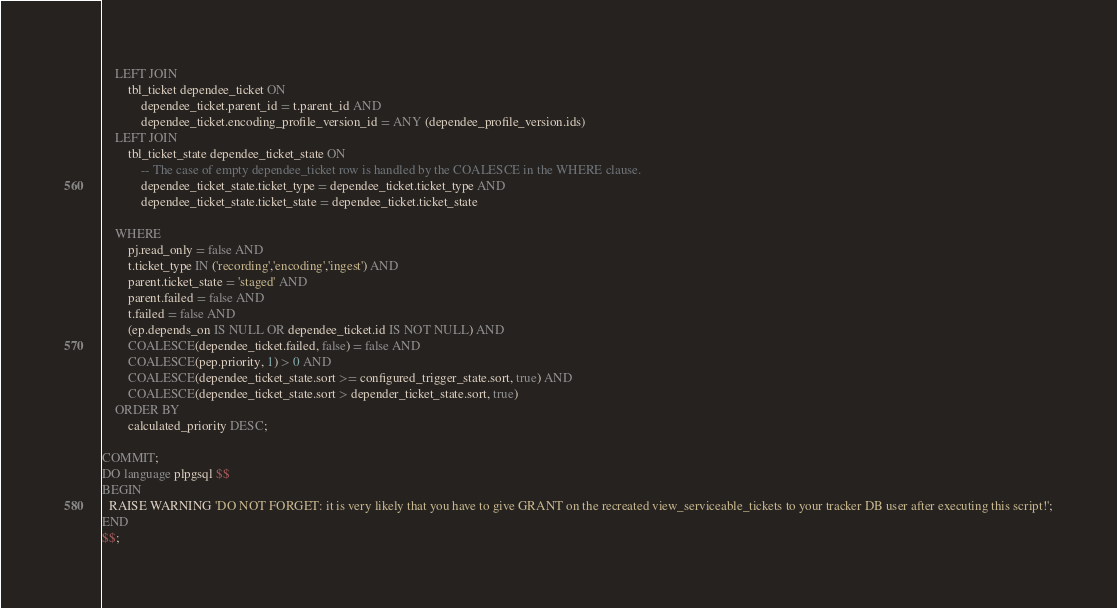<code> <loc_0><loc_0><loc_500><loc_500><_SQL_>	LEFT JOIN
		tbl_ticket dependee_ticket ON
			dependee_ticket.parent_id = t.parent_id AND
			dependee_ticket.encoding_profile_version_id = ANY (dependee_profile_version.ids)
	LEFT JOIN
		tbl_ticket_state dependee_ticket_state ON
			-- The case of empty dependee_ticket row is handled by the COALESCE in the WHERE clause.
			dependee_ticket_state.ticket_type = dependee_ticket.ticket_type AND
			dependee_ticket_state.ticket_state = dependee_ticket.ticket_state

	WHERE
		pj.read_only = false AND
		t.ticket_type IN ('recording','encoding','ingest') AND
		parent.ticket_state = 'staged' AND
		parent.failed = false AND
		t.failed = false AND
		(ep.depends_on IS NULL OR dependee_ticket.id IS NOT NULL) AND
		COALESCE(dependee_ticket.failed, false) = false AND
		COALESCE(pep.priority, 1) > 0 AND
		COALESCE(dependee_ticket_state.sort >= configured_trigger_state.sort, true) AND
		COALESCE(dependee_ticket_state.sort > depender_ticket_state.sort, true)
	ORDER BY
		calculated_priority DESC;

COMMIT;
DO language plpgsql $$
BEGIN
  RAISE WARNING 'DO NOT FORGET: it is very likely that you have to give GRANT on the recreated view_serviceable_tickets to your tracker DB user after executing this script!';
END
$$;

</code> 